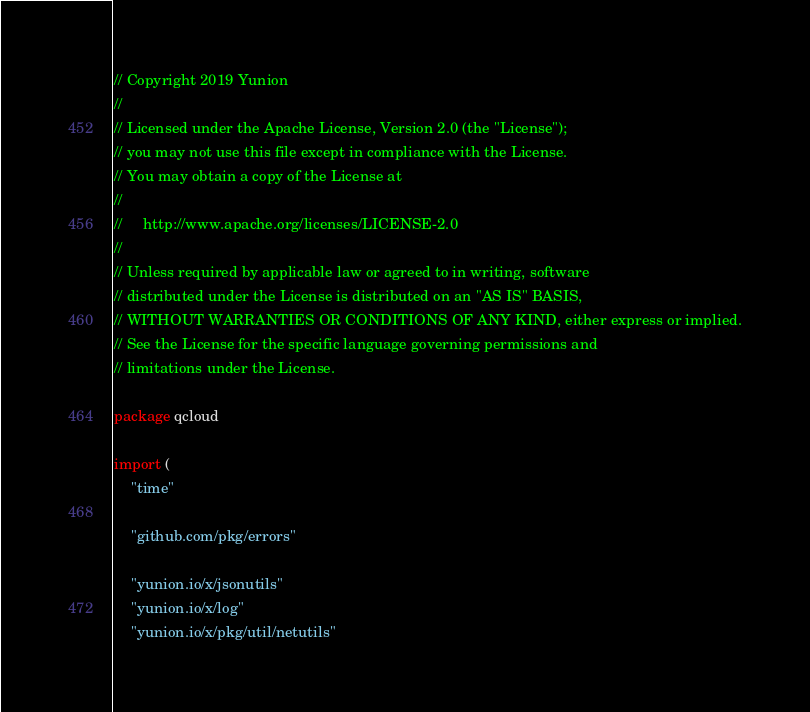<code> <loc_0><loc_0><loc_500><loc_500><_Go_>// Copyright 2019 Yunion
//
// Licensed under the Apache License, Version 2.0 (the "License");
// you may not use this file except in compliance with the License.
// You may obtain a copy of the License at
//
//     http://www.apache.org/licenses/LICENSE-2.0
//
// Unless required by applicable law or agreed to in writing, software
// distributed under the License is distributed on an "AS IS" BASIS,
// WITHOUT WARRANTIES OR CONDITIONS OF ANY KIND, either express or implied.
// See the License for the specific language governing permissions and
// limitations under the License.

package qcloud

import (
	"time"

	"github.com/pkg/errors"

	"yunion.io/x/jsonutils"
	"yunion.io/x/log"
	"yunion.io/x/pkg/util/netutils"
</code> 